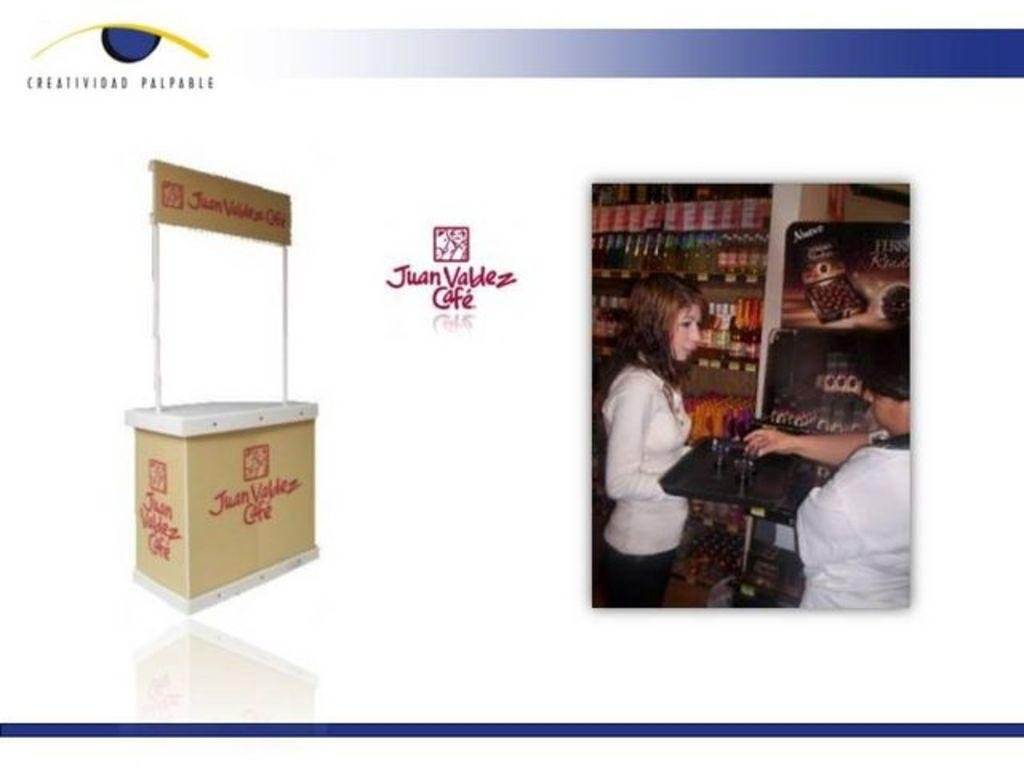What type of establishment is depicted in the image? There is a stall in the image. How many people can be seen in the image? There are two people in the image. What items are on the table in the image? There is a table with glasses on it in the image. Where are the bottles located in the image? The bottles are present on shelves in the image. What visual elements can be found in the image that represent a brand or company? There are logos in the image. What type of written information is present in the image? There is some text in the image. What color is the orange that the bat is holding in the image? There is no bat or orange present in the image. 